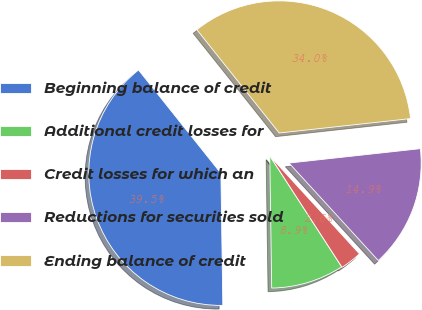<chart> <loc_0><loc_0><loc_500><loc_500><pie_chart><fcel>Beginning balance of credit<fcel>Additional credit losses for<fcel>Credit losses for which an<fcel>Reductions for securities sold<fcel>Ending balance of credit<nl><fcel>39.52%<fcel>8.92%<fcel>2.65%<fcel>14.94%<fcel>33.98%<nl></chart> 